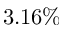Convert formula to latex. <formula><loc_0><loc_0><loc_500><loc_500>3 . 1 6 \%</formula> 